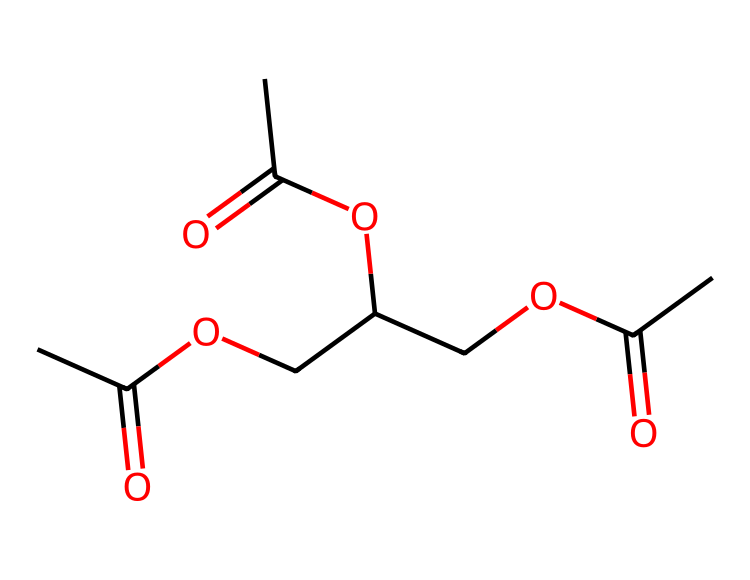What is the functional group present in triacetin? The functional group in triacetin is an ester, which is indicated by the presence of the -COO- linkage between carbonyl (C=O) groups and ether (R-O-R) parts in the structure.
Answer: ester How many carbon atoms are in triacetin? By analyzing the SMILES representation, we count the number of "C" symbols. In triacetin, there are nine carbon atoms present, as seen in the structure.
Answer: nine What is the total number of oxygen atoms in triacetin? In the provided SMILES, every "O" represents an oxygen atom. Counting the occurrences shows there are four oxygen atoms in total in the structure of triacetin.
Answer: four What role does triacetin serve in medical applications? Triacetin is primarily used as a plasticizer, enhancing the flexibility and workability of medical adhesives and bandages.
Answer: plasticizer What type of reaction is involved in forming triacetin? The formation of triacetin from glycerol and acetic acid involves a condensation reaction, which typically produces an ester and water.
Answer: condensation Which part of the triacetin structure indicates it is a tri-ester? The presence of three acetyl (-C(=O)CH3) groups connected to a glycerol backbone shows that triacetin is a tri-ester, highlighting its multi-functional ester nature.
Answer: three acetyl groups What follows after removing the ester linkages from triacetin? Removing the ester linkages from triacetin reveals glycerol, a triol that can participate in various biological processes, including serving as a humectant.
Answer: glycerol 